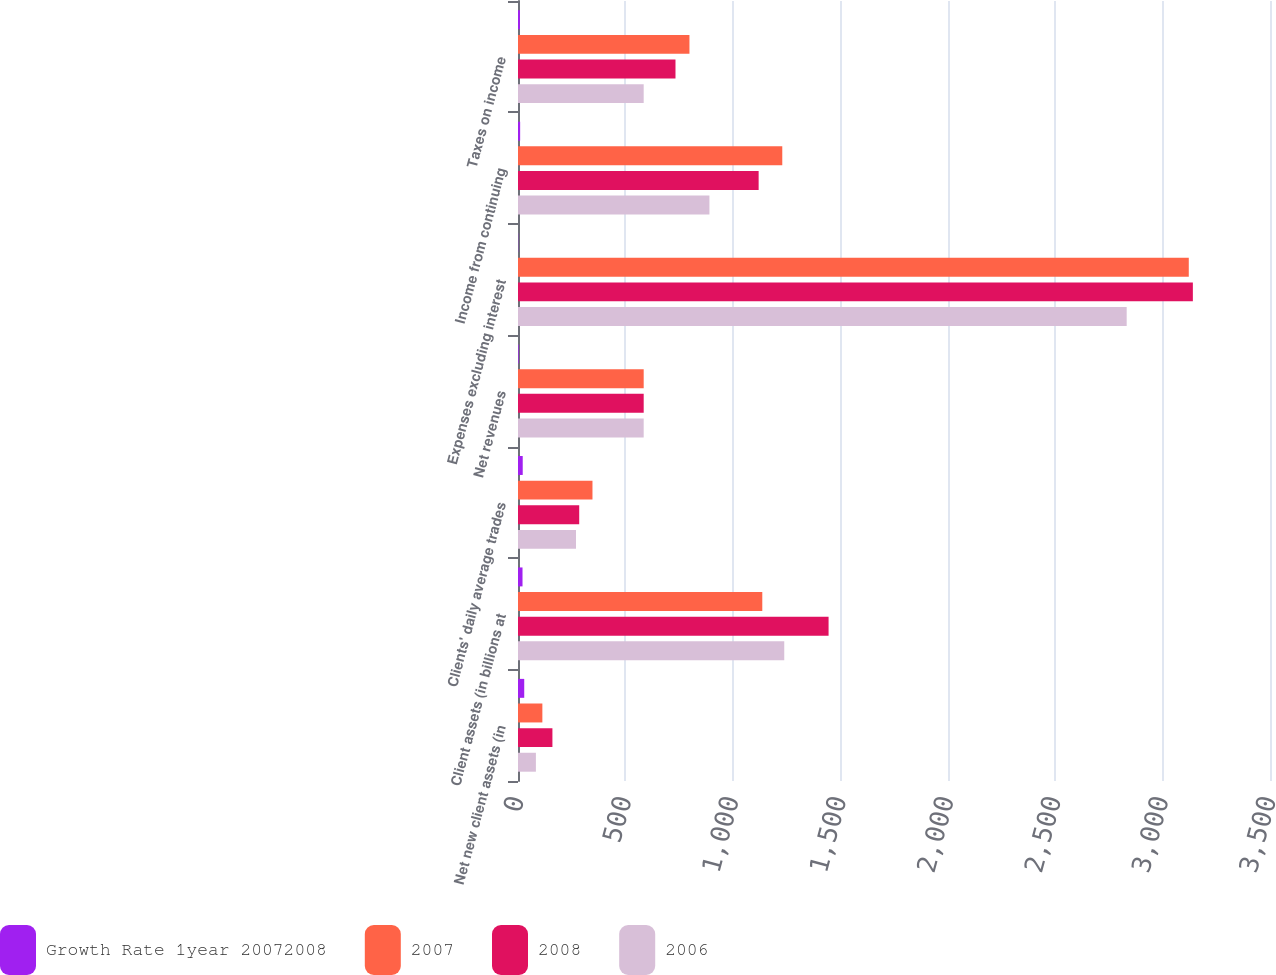Convert chart to OTSL. <chart><loc_0><loc_0><loc_500><loc_500><stacked_bar_chart><ecel><fcel>Net new client assets (in<fcel>Client assets (in billions at<fcel>Clients' daily average trades<fcel>Net revenues<fcel>Expenses excluding interest<fcel>Income from continuing<fcel>Taxes on income<nl><fcel>Growth Rate 1year 20072008<fcel>29<fcel>21<fcel>22<fcel>3<fcel>1<fcel>10<fcel>9<nl><fcel>2007<fcel>113.4<fcel>1137<fcel>346.6<fcel>585<fcel>3122<fcel>1230<fcel>798<nl><fcel>2008<fcel>160.2<fcel>1445.5<fcel>284.9<fcel>585<fcel>3141<fcel>1120<fcel>733<nl><fcel>2006<fcel>83.3<fcel>1239.2<fcel>270<fcel>585<fcel>2833<fcel>891<fcel>585<nl></chart> 